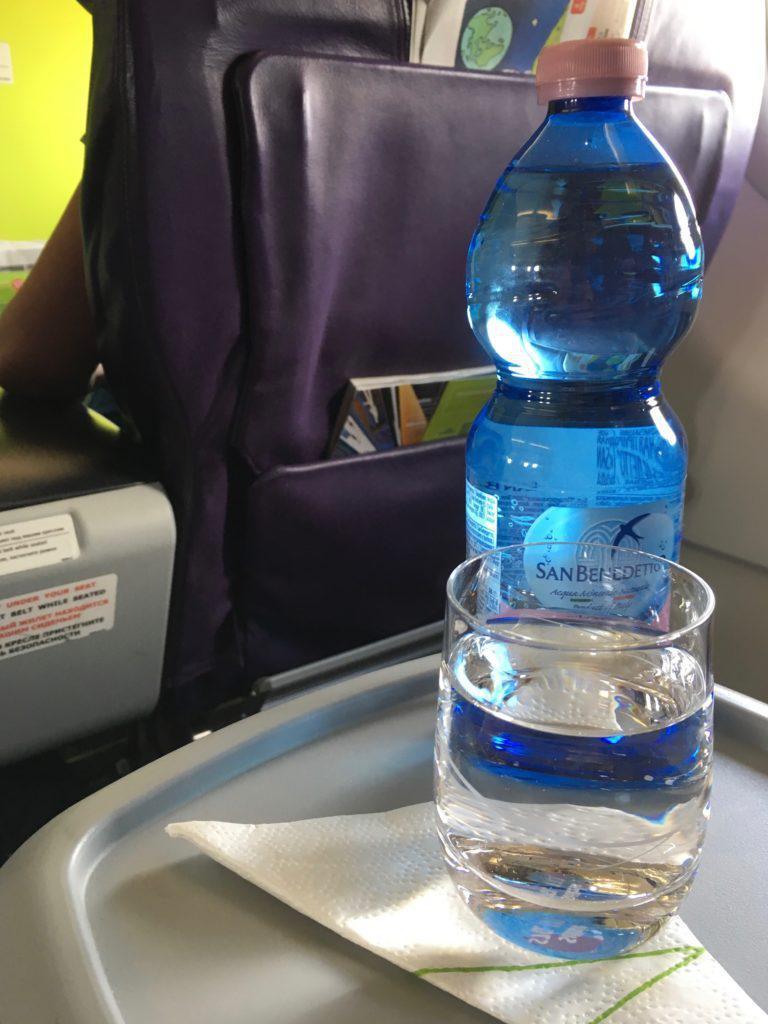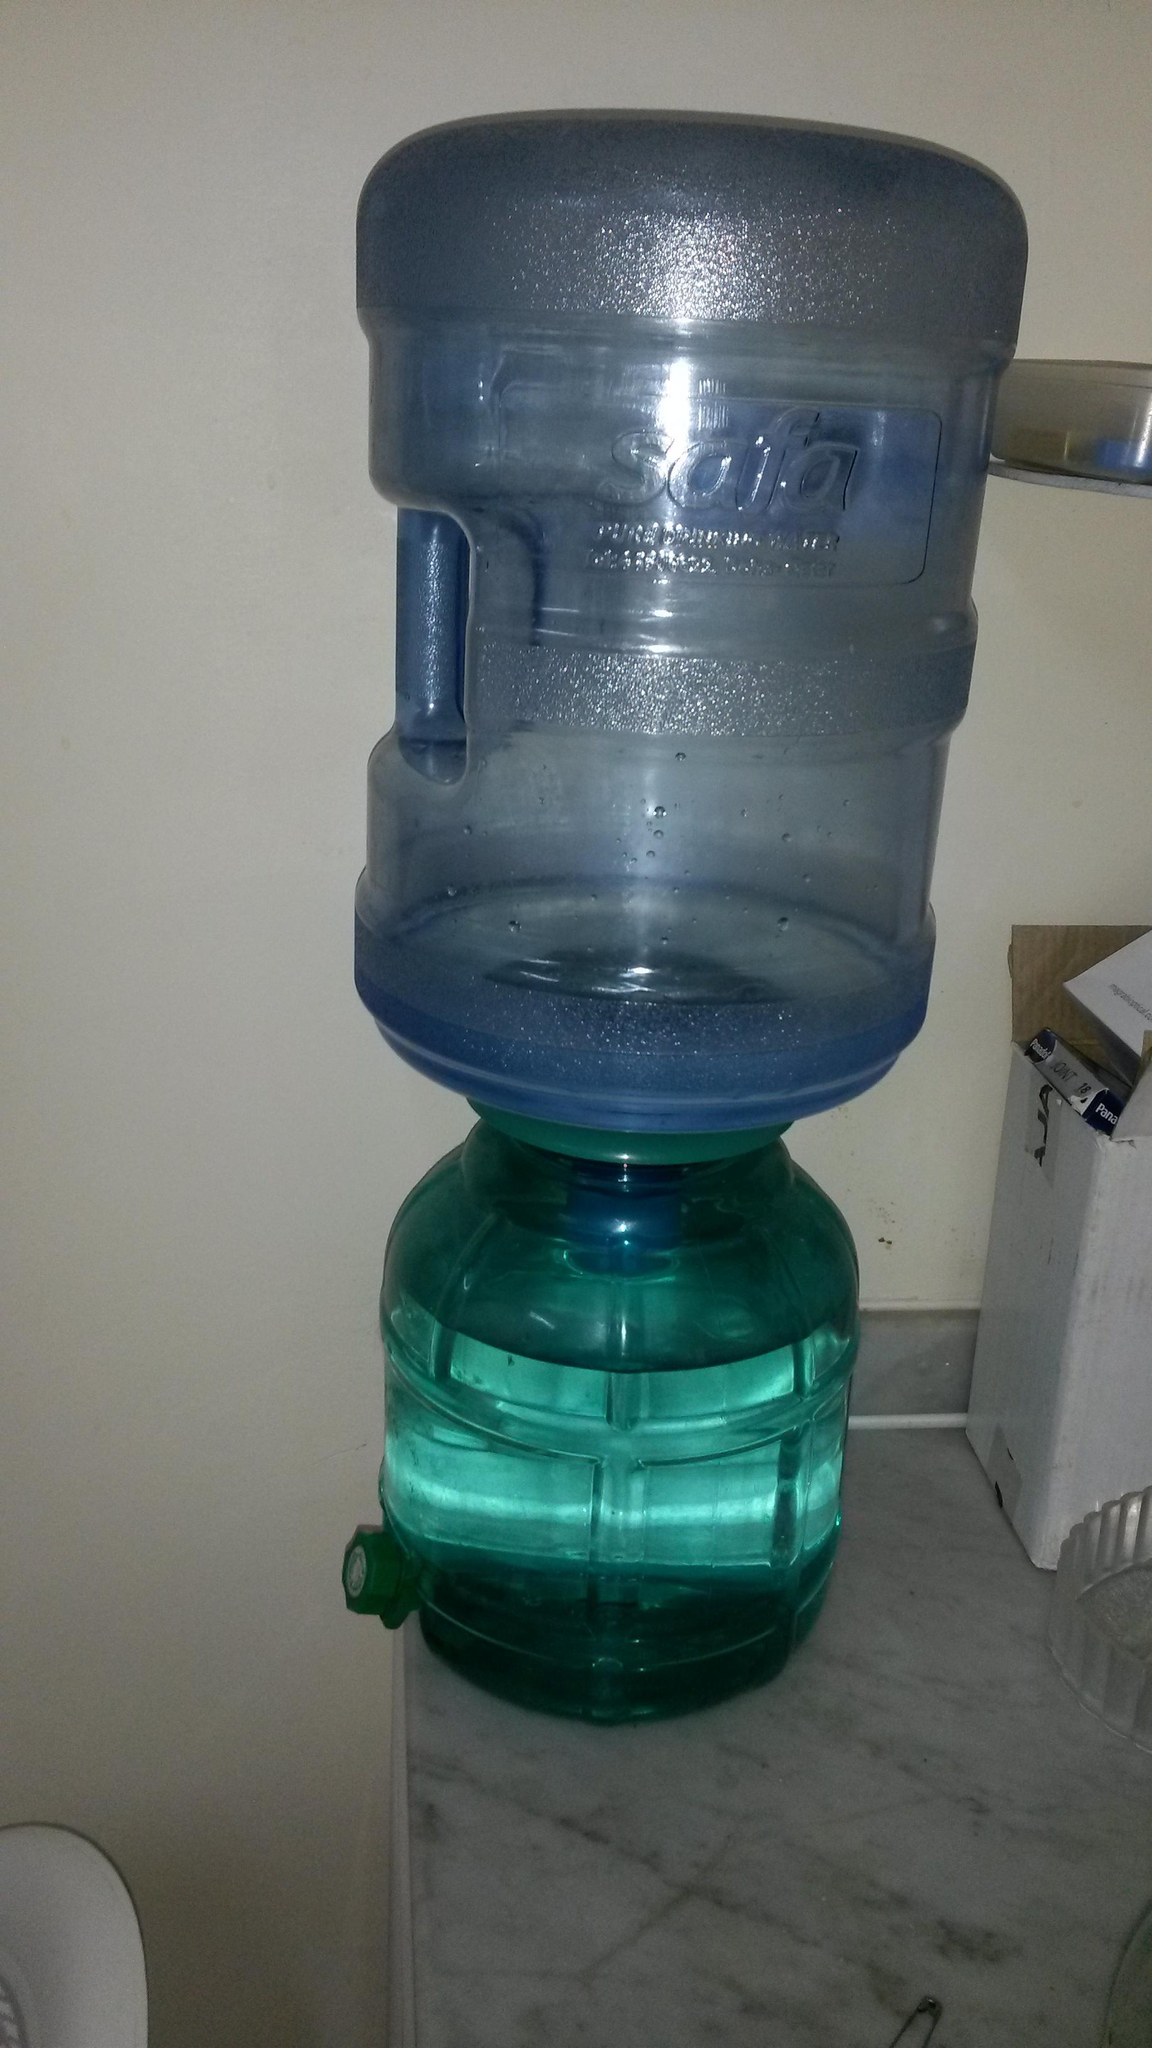The first image is the image on the left, the second image is the image on the right. Examine the images to the left and right. Is the description "An image shows at least one water jug stacked inverted on upright jugs." accurate? Answer yes or no. No. The first image is the image on the left, the second image is the image on the right. For the images shown, is this caption "There are more than three water containers standing up." true? Answer yes or no. No. 